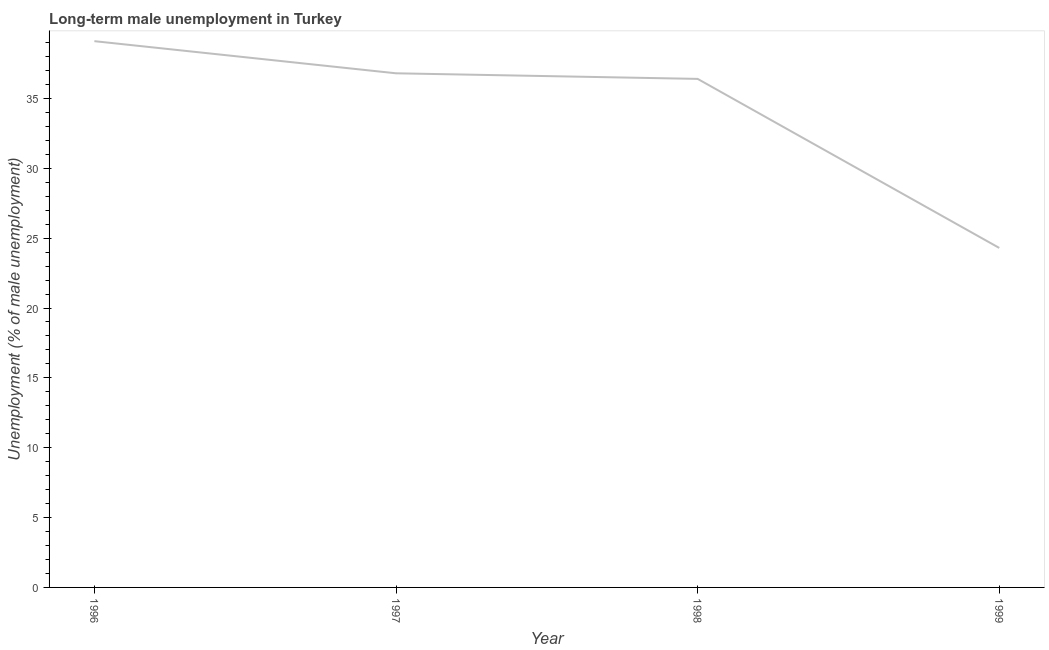What is the long-term male unemployment in 1997?
Give a very brief answer. 36.8. Across all years, what is the maximum long-term male unemployment?
Ensure brevity in your answer.  39.1. Across all years, what is the minimum long-term male unemployment?
Make the answer very short. 24.3. In which year was the long-term male unemployment minimum?
Keep it short and to the point. 1999. What is the sum of the long-term male unemployment?
Your answer should be compact. 136.6. What is the difference between the long-term male unemployment in 1996 and 1999?
Offer a terse response. 14.8. What is the average long-term male unemployment per year?
Offer a very short reply. 34.15. What is the median long-term male unemployment?
Your response must be concise. 36.6. In how many years, is the long-term male unemployment greater than 31 %?
Ensure brevity in your answer.  3. What is the ratio of the long-term male unemployment in 1997 to that in 1999?
Your answer should be very brief. 1.51. Is the long-term male unemployment in 1998 less than that in 1999?
Give a very brief answer. No. Is the difference between the long-term male unemployment in 1997 and 1999 greater than the difference between any two years?
Make the answer very short. No. What is the difference between the highest and the second highest long-term male unemployment?
Offer a very short reply. 2.3. What is the difference between the highest and the lowest long-term male unemployment?
Make the answer very short. 14.8. What is the difference between two consecutive major ticks on the Y-axis?
Make the answer very short. 5. Are the values on the major ticks of Y-axis written in scientific E-notation?
Offer a very short reply. No. Does the graph contain any zero values?
Keep it short and to the point. No. Does the graph contain grids?
Offer a terse response. No. What is the title of the graph?
Provide a short and direct response. Long-term male unemployment in Turkey. What is the label or title of the X-axis?
Provide a succinct answer. Year. What is the label or title of the Y-axis?
Make the answer very short. Unemployment (% of male unemployment). What is the Unemployment (% of male unemployment) of 1996?
Provide a succinct answer. 39.1. What is the Unemployment (% of male unemployment) in 1997?
Offer a very short reply. 36.8. What is the Unemployment (% of male unemployment) of 1998?
Your answer should be very brief. 36.4. What is the Unemployment (% of male unemployment) of 1999?
Make the answer very short. 24.3. What is the difference between the Unemployment (% of male unemployment) in 1996 and 1998?
Offer a terse response. 2.7. What is the difference between the Unemployment (% of male unemployment) in 1996 and 1999?
Your answer should be very brief. 14.8. What is the difference between the Unemployment (% of male unemployment) in 1997 and 1999?
Keep it short and to the point. 12.5. What is the difference between the Unemployment (% of male unemployment) in 1998 and 1999?
Keep it short and to the point. 12.1. What is the ratio of the Unemployment (% of male unemployment) in 1996 to that in 1997?
Provide a succinct answer. 1.06. What is the ratio of the Unemployment (% of male unemployment) in 1996 to that in 1998?
Your answer should be very brief. 1.07. What is the ratio of the Unemployment (% of male unemployment) in 1996 to that in 1999?
Your answer should be very brief. 1.61. What is the ratio of the Unemployment (% of male unemployment) in 1997 to that in 1999?
Provide a short and direct response. 1.51. What is the ratio of the Unemployment (% of male unemployment) in 1998 to that in 1999?
Make the answer very short. 1.5. 